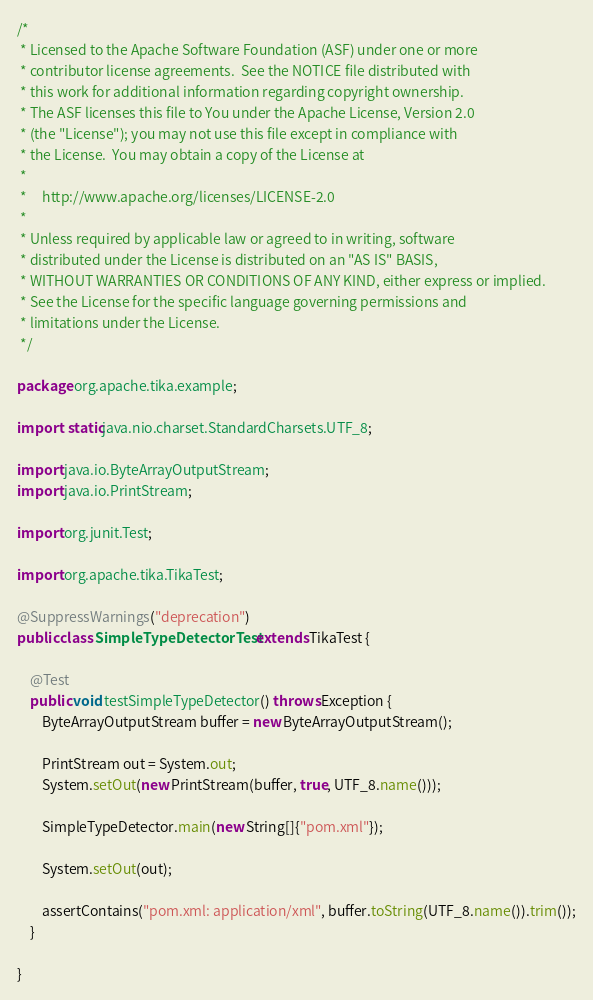<code> <loc_0><loc_0><loc_500><loc_500><_Java_>/*
 * Licensed to the Apache Software Foundation (ASF) under one or more
 * contributor license agreements.  See the NOTICE file distributed with
 * this work for additional information regarding copyright ownership.
 * The ASF licenses this file to You under the Apache License, Version 2.0
 * (the "License"); you may not use this file except in compliance with
 * the License.  You may obtain a copy of the License at
 *
 *     http://www.apache.org/licenses/LICENSE-2.0
 *
 * Unless required by applicable law or agreed to in writing, software
 * distributed under the License is distributed on an "AS IS" BASIS,
 * WITHOUT WARRANTIES OR CONDITIONS OF ANY KIND, either express or implied.
 * See the License for the specific language governing permissions and
 * limitations under the License.
 */

package org.apache.tika.example;

import static java.nio.charset.StandardCharsets.UTF_8;

import java.io.ByteArrayOutputStream;
import java.io.PrintStream;

import org.junit.Test;

import org.apache.tika.TikaTest;

@SuppressWarnings("deprecation")
public class SimpleTypeDetectorTest extends TikaTest {

    @Test
    public void testSimpleTypeDetector() throws Exception {
        ByteArrayOutputStream buffer = new ByteArrayOutputStream();

        PrintStream out = System.out;
        System.setOut(new PrintStream(buffer, true, UTF_8.name()));

        SimpleTypeDetector.main(new String[]{"pom.xml"});

        System.setOut(out);

        assertContains("pom.xml: application/xml", buffer.toString(UTF_8.name()).trim());
    }

}
</code> 